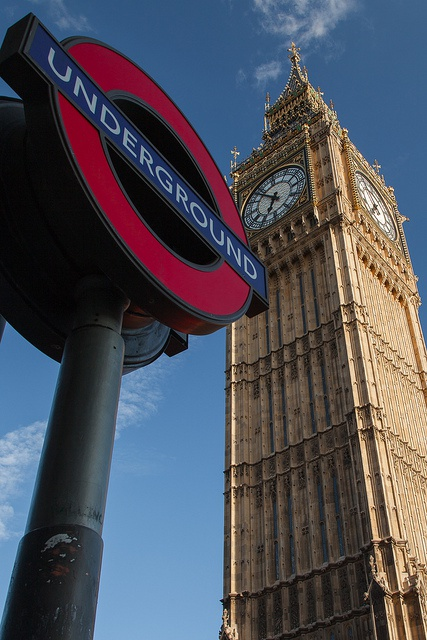Describe the objects in this image and their specific colors. I can see clock in blue, black, gray, and darkgray tones and clock in blue, white, darkgray, tan, and gray tones in this image. 